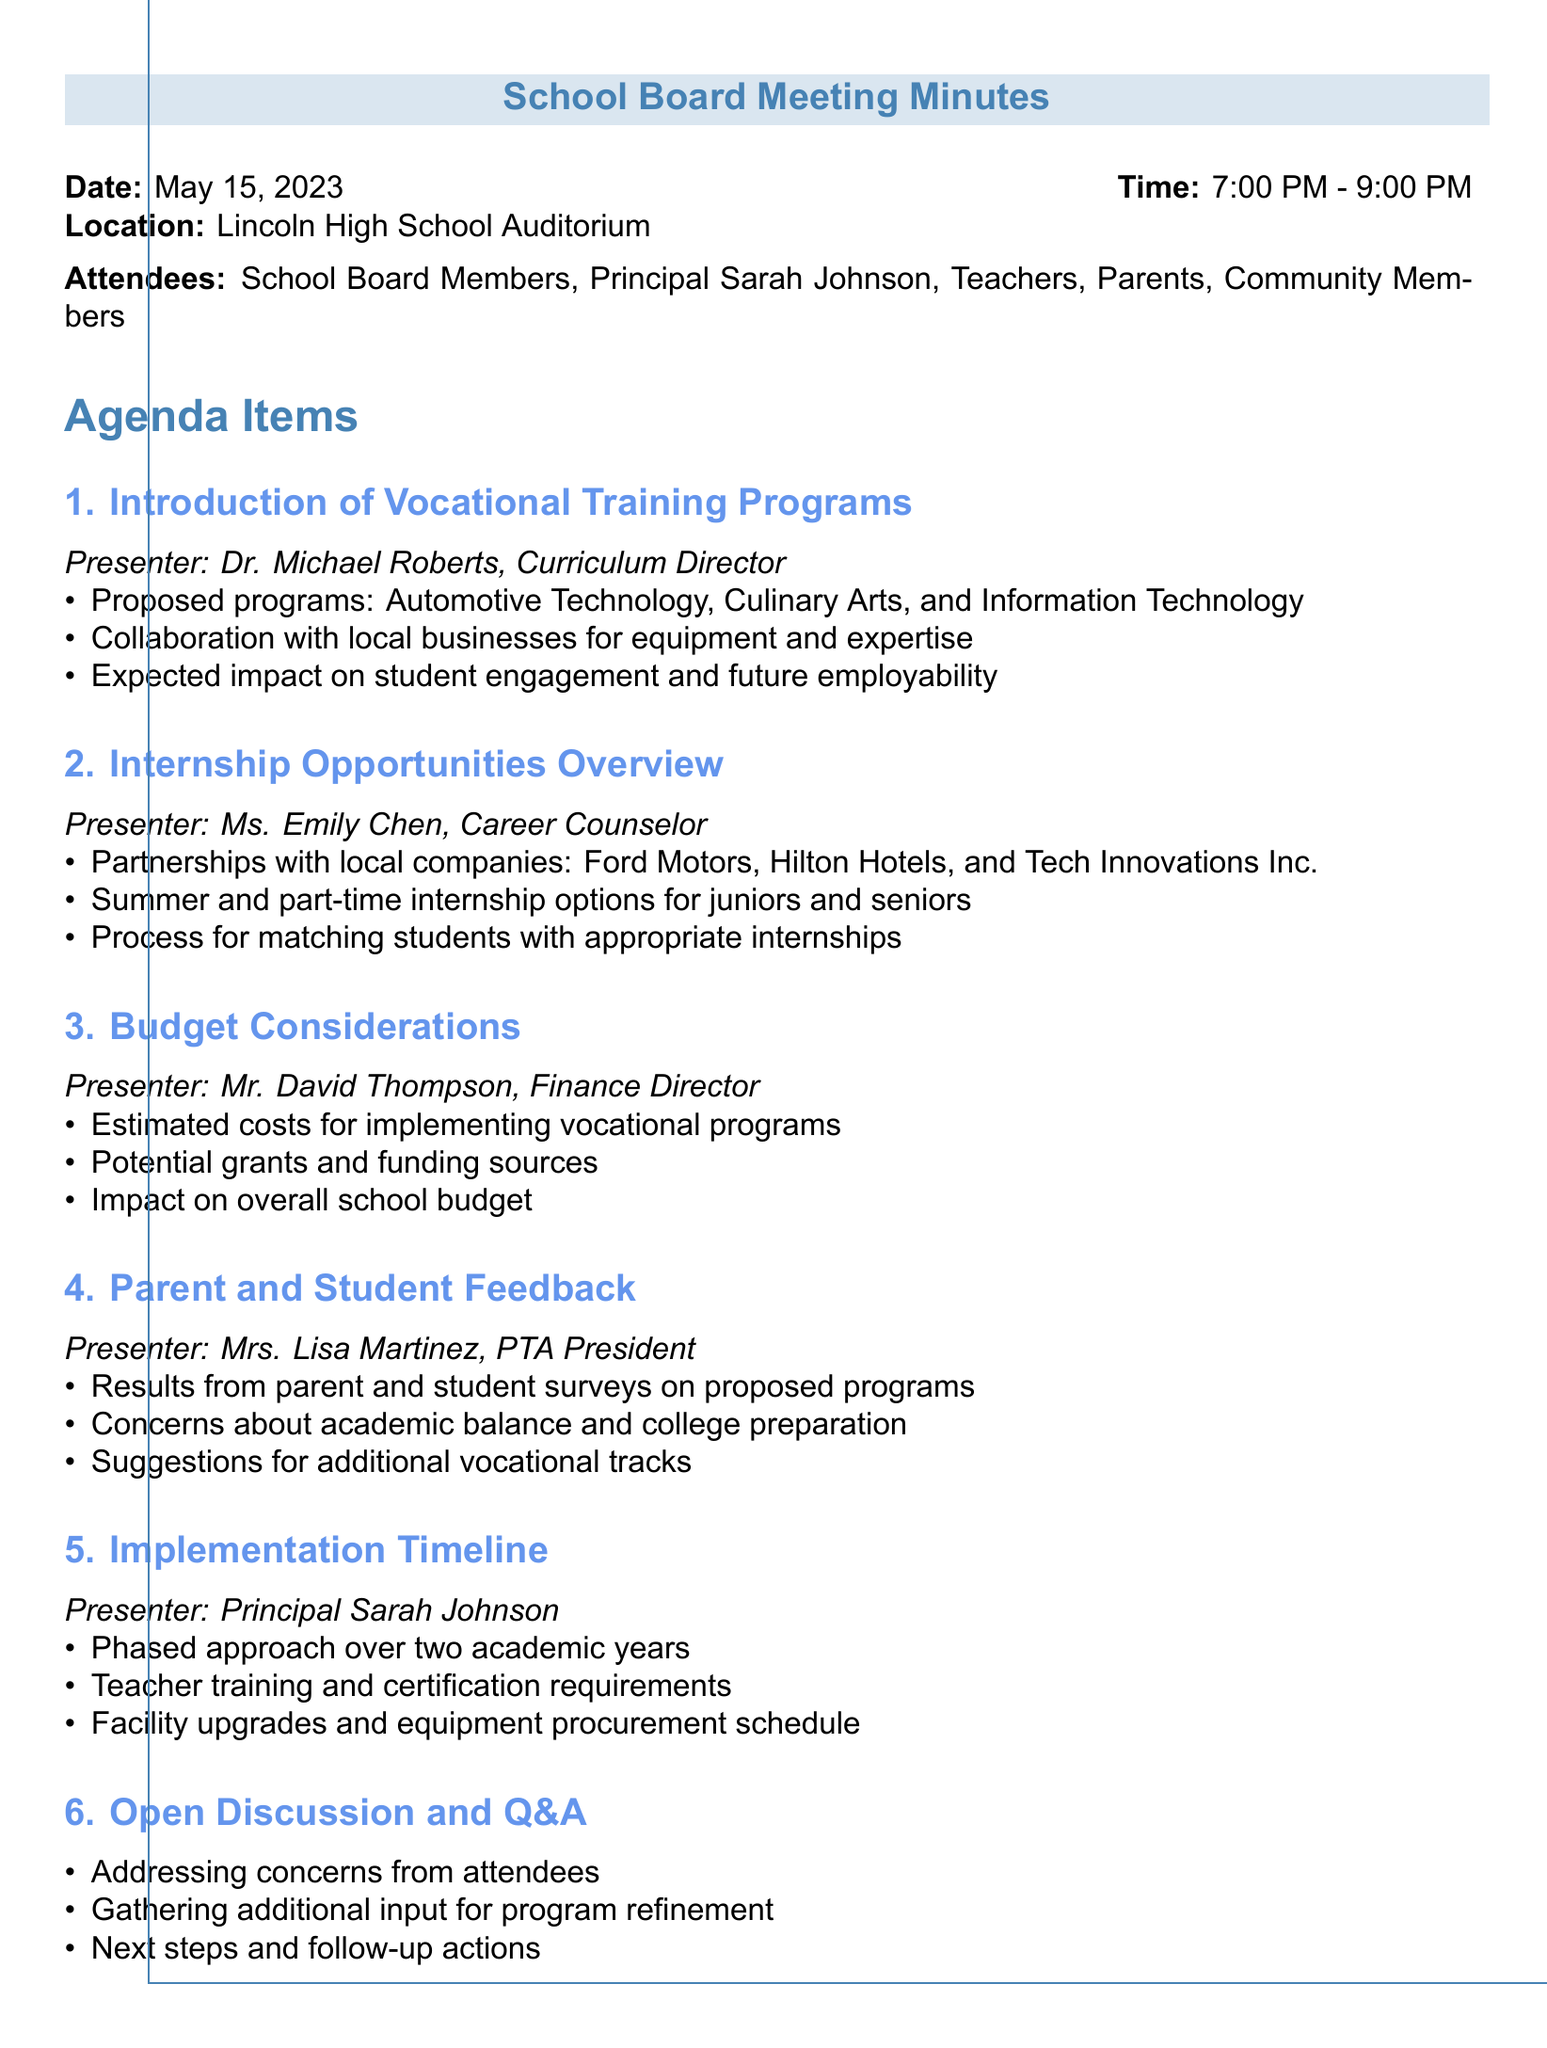What is the date of the meeting? The date of the meeting is stated clearly in the document as May 15, 2023.
Answer: May 15, 2023 Who presented the internship opportunities overview? The document mentions Ms. Emily Chen as the presenter for the internship opportunities overview.
Answer: Ms. Emily Chen What are the proposed vocational programs? The document lists Automotive Technology, Culinary Arts, and Information Technology as the proposed vocational programs.
Answer: Automotive Technology, Culinary Arts, Information Technology What is the duration of the implementation timeline? The timeline for implementation is mentioned to span over two academic years in the document.
Answer: Two academic years What concerns did parents express regarding the programs? The document states that concerns about academic balance and college preparation were raised by parents during the feedback session.
Answer: Academic balance and college preparation Which company is mentioned as a partner for internship opportunities? The document lists Ford Motors as one of the partnerships for providing internship opportunities.
Answer: Ford Motors What is the purpose of the open discussion and Q&A segment? The document indicates that the purpose includes addressing concerns from attendees and gathering additional input for program refinement.
Answer: Addressing concerns and gathering input What does the budget considerations section focus on? The document outlines that the budget considerations focus on estimated costs for implementing vocational programs and potential grants and funding sources.
Answer: Estimated costs and potential grants Who is responsible for the phased approach in the implementation timeline? The document indicates that Principal Sarah Johnson is responsible for the phased approach in the implementation timeline.
Answer: Principal Sarah Johnson 